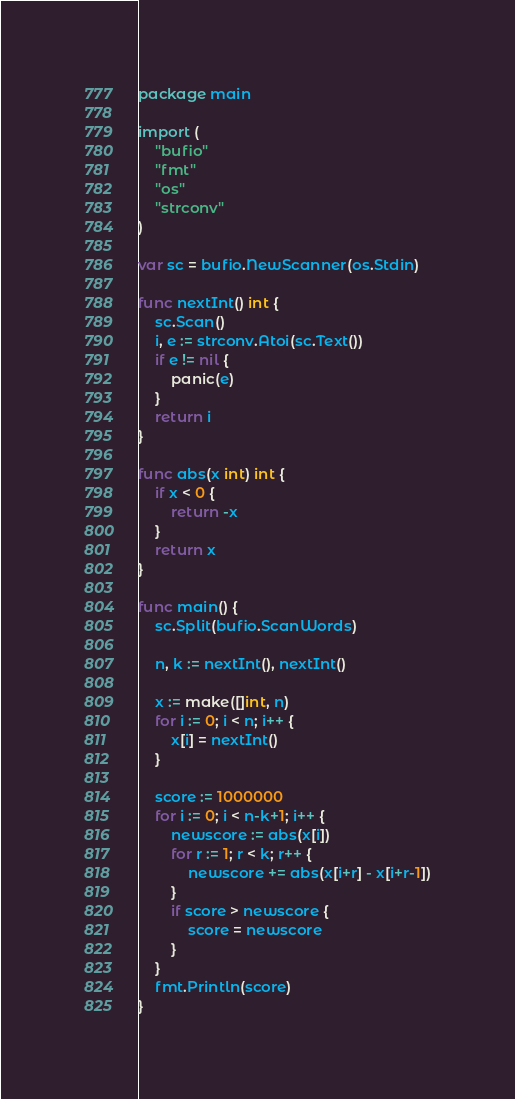Convert code to text. <code><loc_0><loc_0><loc_500><loc_500><_Go_>package main

import (
	"bufio"
	"fmt"
	"os"
	"strconv"
)

var sc = bufio.NewScanner(os.Stdin)

func nextInt() int {
	sc.Scan()
	i, e := strconv.Atoi(sc.Text())
	if e != nil {
		panic(e)
	}
	return i
}

func abs(x int) int {
	if x < 0 {
		return -x
	}
	return x
}

func main() {
	sc.Split(bufio.ScanWords)

	n, k := nextInt(), nextInt()

	x := make([]int, n)
	for i := 0; i < n; i++ {
		x[i] = nextInt()
	}

	score := 1000000
	for i := 0; i < n-k+1; i++ {
		newscore := abs(x[i])
		for r := 1; r < k; r++ {
			newscore += abs(x[i+r] - x[i+r-1])
		}
		if score > newscore {
			score = newscore
		}
	}
	fmt.Println(score)
}
</code> 